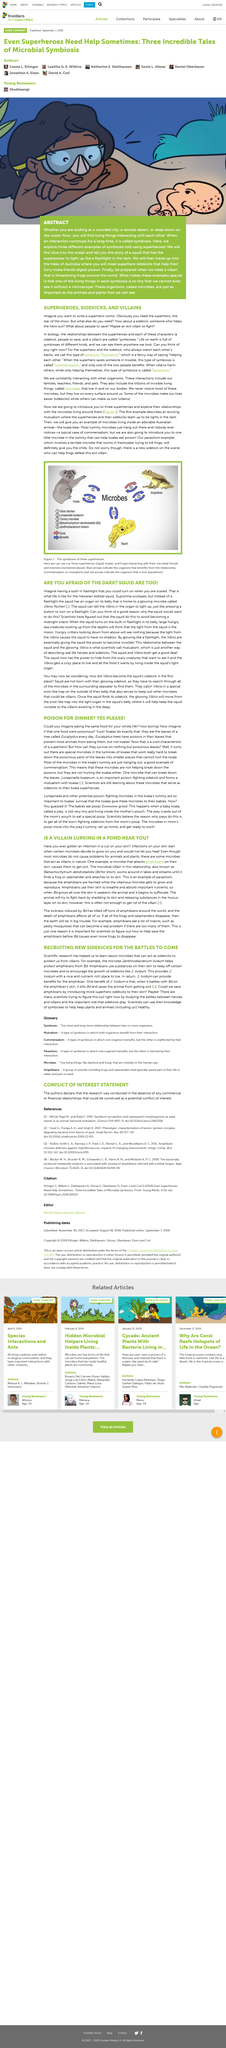Point out several critical features in this image. Eucalyptus is the name of the tree that koalas primarily feed on. The microbe known as Lonepinella koalarum, found in the special poop consumed by baby koalas, is now officially recognized by scientists. Batrachocytrium dendrobatidis is considered a villainous microbe in this article, which is viewed as the culprit in ponds. Amphibians, which also known as the "globe's most ancient creatures" and "primitive creatures", are not only found lurking in ponds, but also swimming in lakes and streams. The relationship between superheroes and sidekicks, commonly referred to as symbiosis, is a dynamic and complex interdependence between two different entities. 